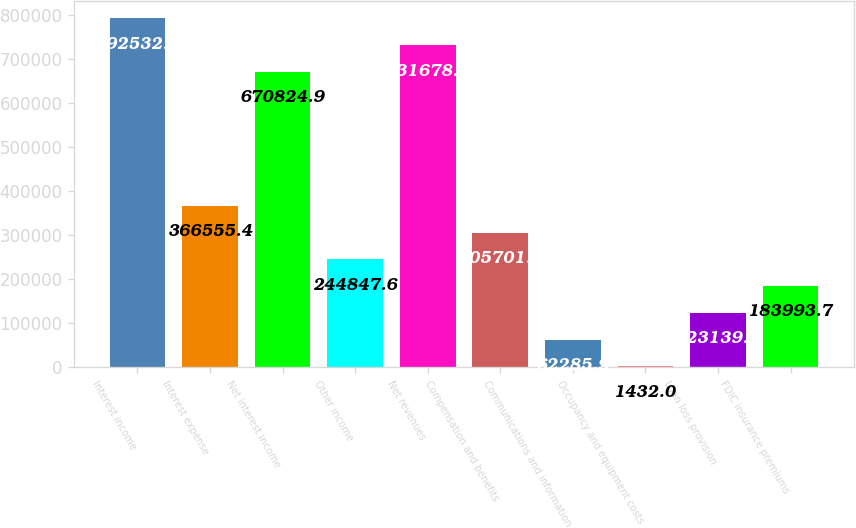<chart> <loc_0><loc_0><loc_500><loc_500><bar_chart><fcel>Interest income<fcel>Interest expense<fcel>Net interest income<fcel>Other income<fcel>Net revenues<fcel>Compensation and benefits<fcel>Communications and information<fcel>Occupancy and equipment costs<fcel>Loan loss provision<fcel>FDIC insurance premiums<nl><fcel>792533<fcel>366555<fcel>670825<fcel>244848<fcel>731679<fcel>305702<fcel>62285.9<fcel>1432<fcel>123140<fcel>183994<nl></chart> 